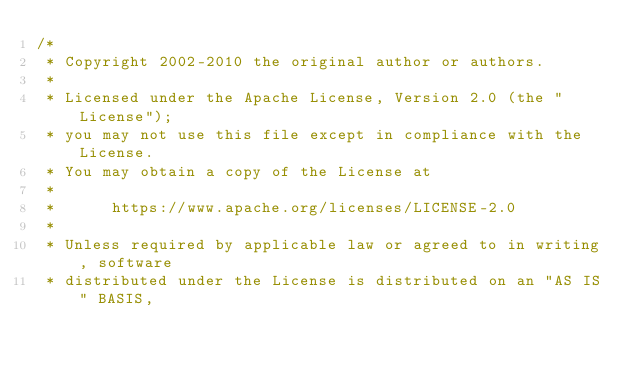<code> <loc_0><loc_0><loc_500><loc_500><_Java_>/*
 * Copyright 2002-2010 the original author or authors.
 *
 * Licensed under the Apache License, Version 2.0 (the "License");
 * you may not use this file except in compliance with the License.
 * You may obtain a copy of the License at
 *
 *      https://www.apache.org/licenses/LICENSE-2.0
 *
 * Unless required by applicable law or agreed to in writing, software
 * distributed under the License is distributed on an "AS IS" BASIS,</code> 